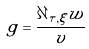<formula> <loc_0><loc_0><loc_500><loc_500>g = \frac { \partial _ { \tau , \xi } w } { v }</formula> 